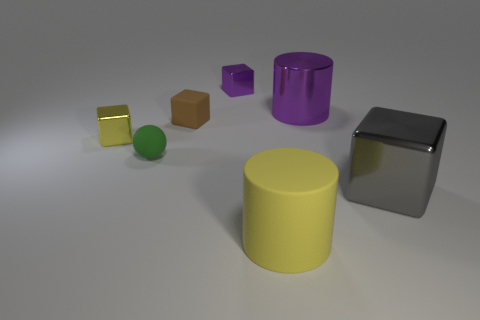Subtract all big metallic cubes. How many cubes are left? 3 Add 2 small yellow metallic things. How many objects exist? 9 Subtract all brown blocks. How many blocks are left? 3 Subtract all balls. How many objects are left? 6 Subtract 2 cylinders. How many cylinders are left? 0 Subtract all blue balls. Subtract all green cubes. How many balls are left? 1 Subtract all cyan cubes. How many purple cylinders are left? 1 Subtract all gray metallic objects. Subtract all big purple cylinders. How many objects are left? 5 Add 4 large yellow objects. How many large yellow objects are left? 5 Add 5 big red shiny spheres. How many big red shiny spheres exist? 5 